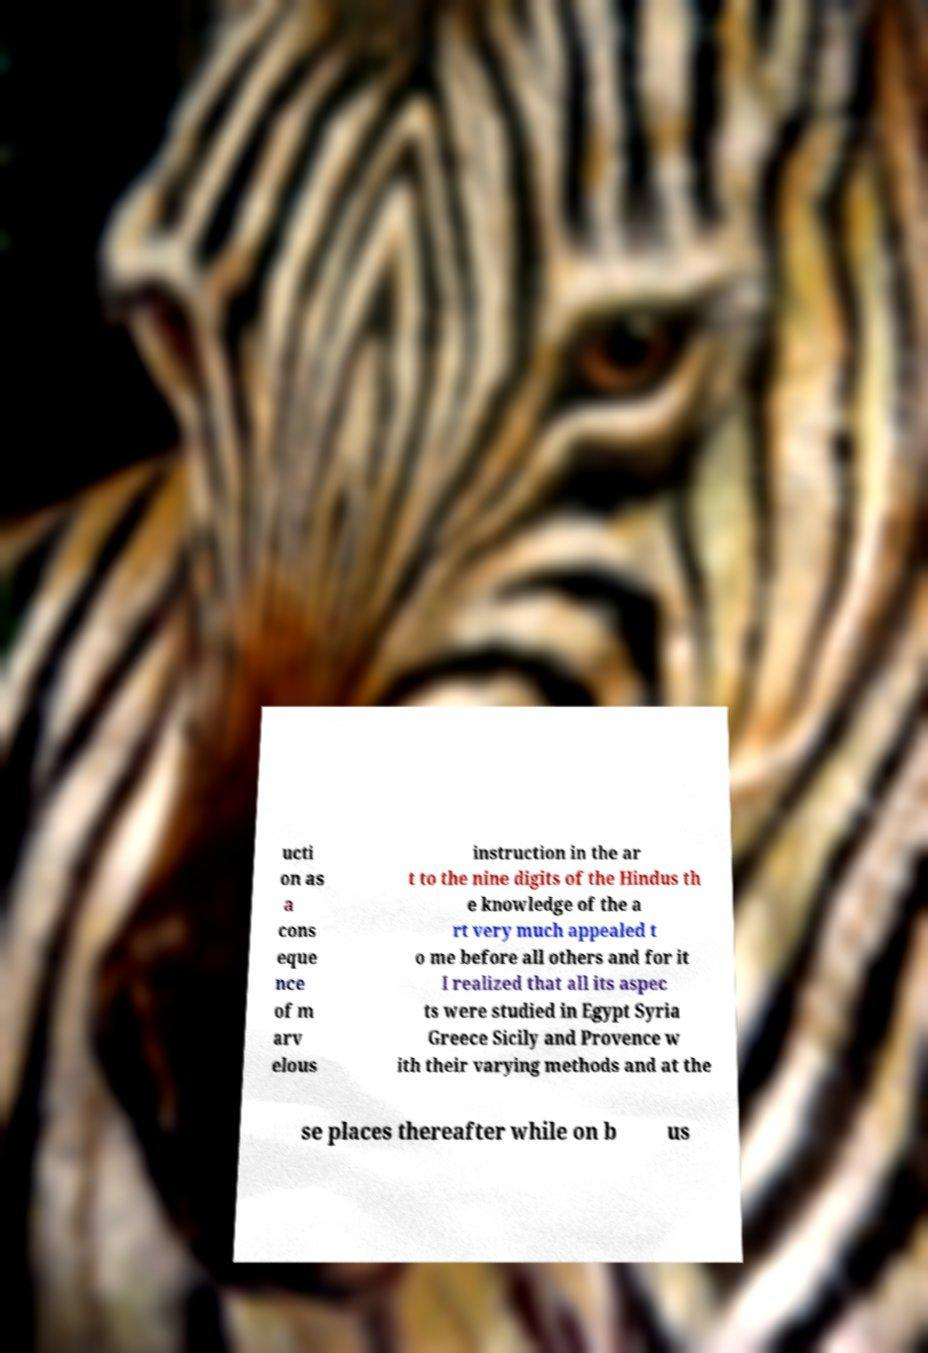Please read and relay the text visible in this image. What does it say? ucti on as a cons eque nce of m arv elous instruction in the ar t to the nine digits of the Hindus th e knowledge of the a rt very much appealed t o me before all others and for it I realized that all its aspec ts were studied in Egypt Syria Greece Sicily and Provence w ith their varying methods and at the se places thereafter while on b us 